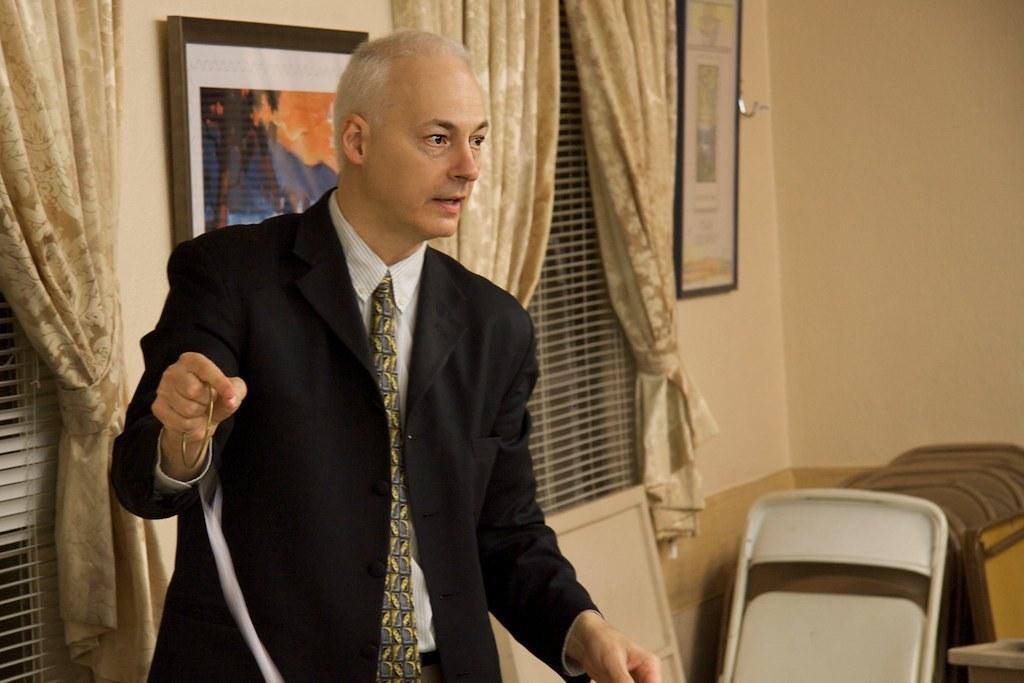What is the man in the image wearing? The man is wearing a blazer and a tie. What is the man holding in his hand? The man is holding a bangle in his hand. What type of furniture is in the image? There is a chair in the image. What can be seen on the wall in the image? There are frames on the wall. What is the condition of the windows in the image? There are windows with curtains in the image. Can you describe any other objects in the image? There are some objects in the image, but their specific details are not mentioned in the provided facts. What type of string is being used to destroy the crown in the image? There is no string, destruction, or crown present in the image. 